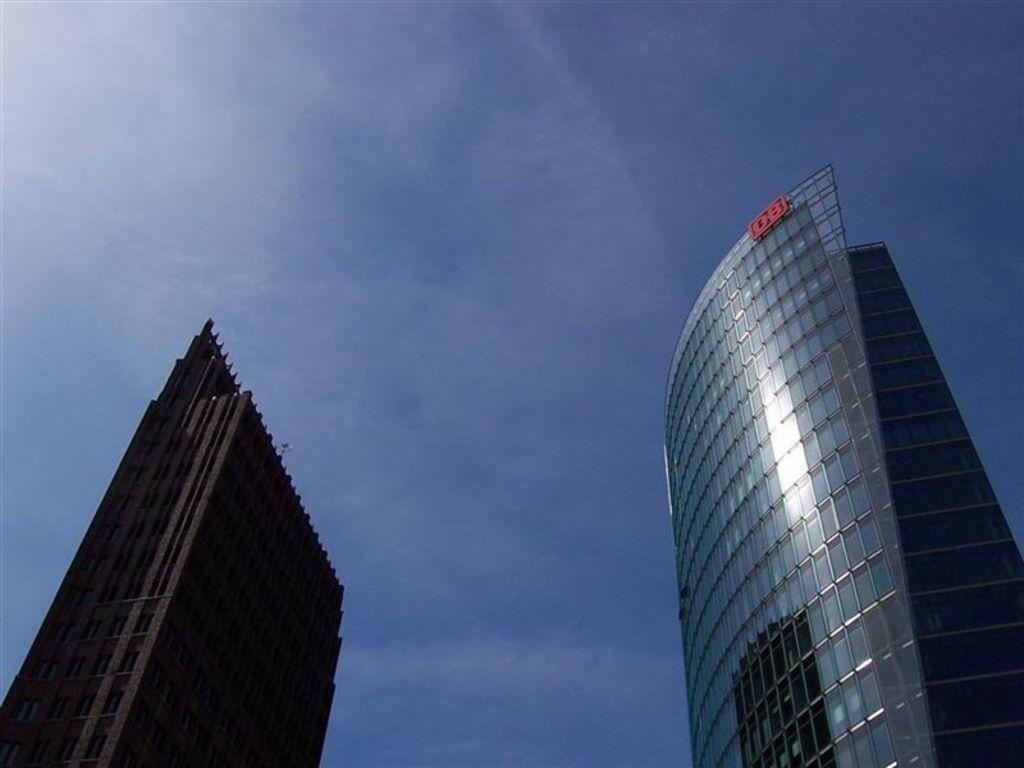How many buildings can be seen in the image? There are two buildings in the image. What material is visible in the image? Glass is visible in the image. What can be seen in the background of the image? The sky is visible in the background of the image. What type of stove is being used by the governor in the image? There is no governor or stove present in the image. 